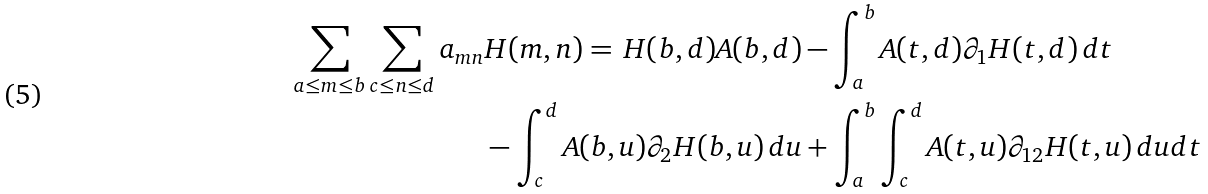Convert formula to latex. <formula><loc_0><loc_0><loc_500><loc_500>\sum _ { a \leq m \leq b } \sum _ { c \leq n \leq d } a _ { m n } & H ( m , n ) = \, H ( b , d ) A ( b , d ) - \int _ { a } ^ { b } A ( t , d ) \partial _ { 1 } H ( t , d ) \, d t \\ & - \int _ { c } ^ { d } A ( b , u ) \partial _ { 2 } H ( b , u ) \, d u + \int _ { a } ^ { b } \int _ { c } ^ { d } A ( t , u ) \partial _ { 1 2 } H ( t , u ) \, d u d t</formula> 